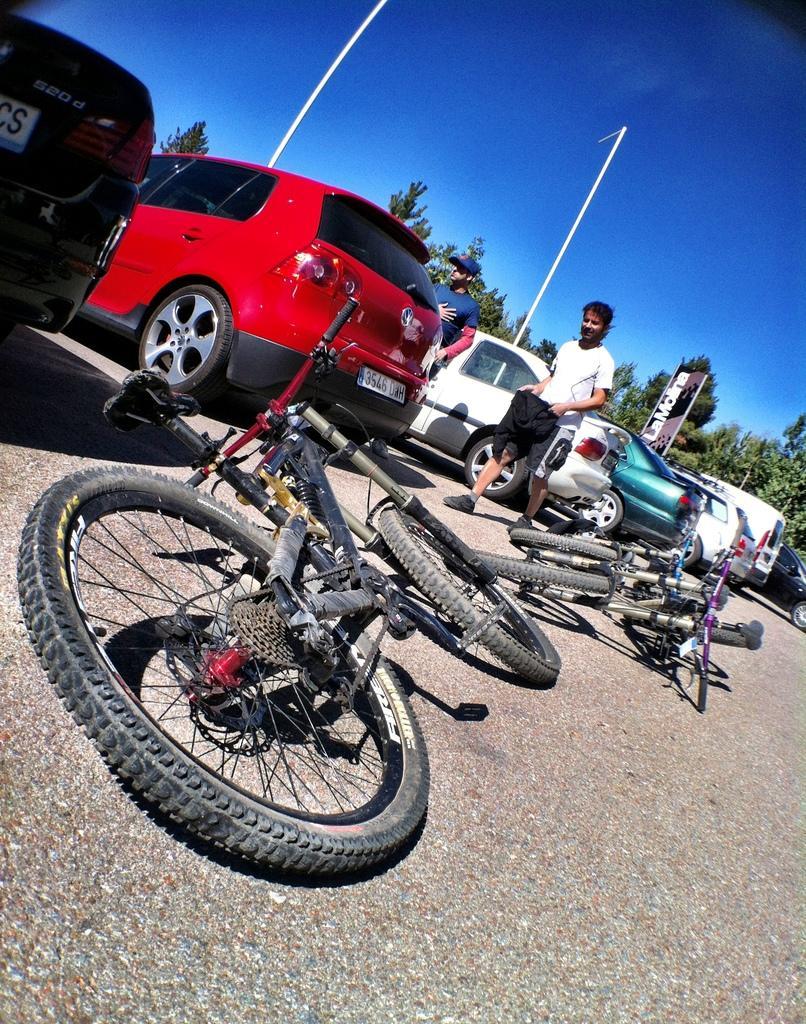Please provide a concise description of this image. At the bottom of the image I can see the road. In the middle of the image I can see vehicles. In the background, I can see groups of trees. There is a sky on the top of this image. 